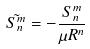Convert formula to latex. <formula><loc_0><loc_0><loc_500><loc_500>\tilde { S _ { n } ^ { m } } = - \frac { S _ { n } ^ { m } } { \mu R ^ { n } }</formula> 